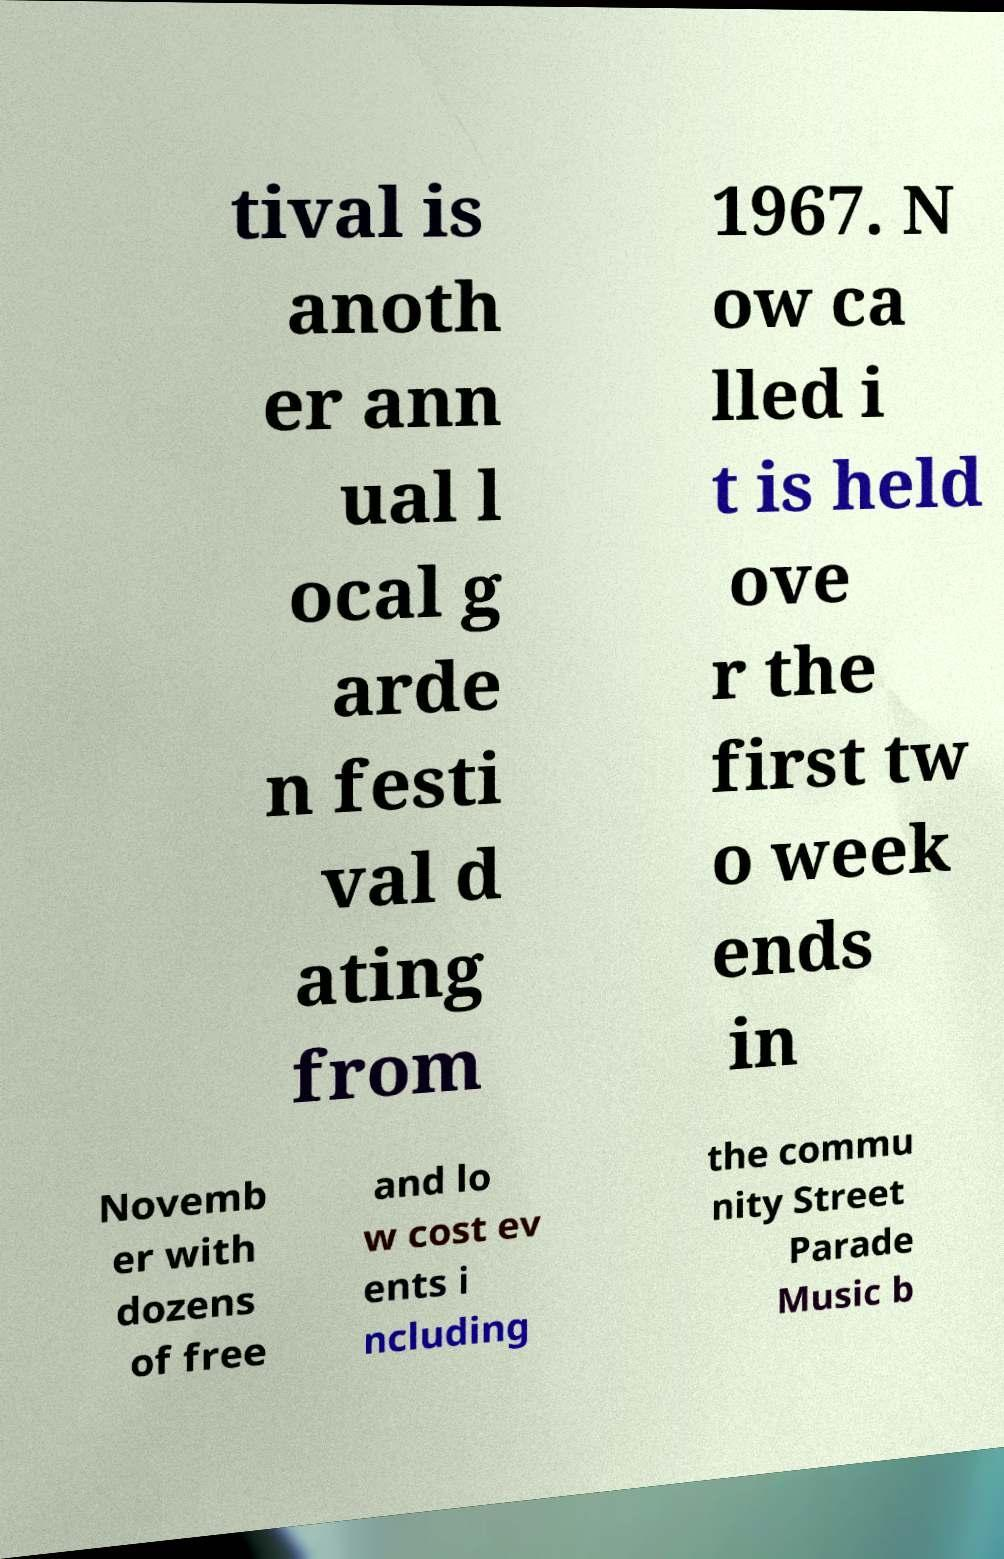There's text embedded in this image that I need extracted. Can you transcribe it verbatim? tival is anoth er ann ual l ocal g arde n festi val d ating from 1967. N ow ca lled i t is held ove r the first tw o week ends in Novemb er with dozens of free and lo w cost ev ents i ncluding the commu nity Street Parade Music b 